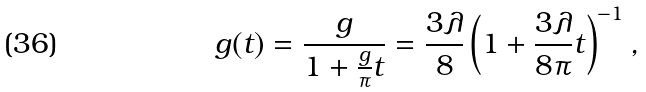Convert formula to latex. <formula><loc_0><loc_0><loc_500><loc_500>g ( t ) = { \frac { g } { 1 + { \frac { g } { \pi } } t } } = { \frac { 3 \lambda } { 8 } } \left ( 1 + { \frac { 3 \lambda } { 8 \pi } } t \right ) ^ { - 1 } ,</formula> 